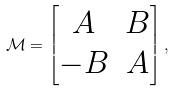<formula> <loc_0><loc_0><loc_500><loc_500>\mathcal { M } = \begin{bmatrix} A & B \\ - B & A \end{bmatrix} ,</formula> 